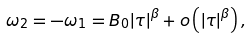Convert formula to latex. <formula><loc_0><loc_0><loc_500><loc_500>\omega _ { 2 } = - \omega _ { 1 } = B _ { 0 } { \left | { \tau } \right | } ^ { \beta } + o \left ( { { \left | { \tau } \right | } ^ { \beta } } \right ) ,</formula> 